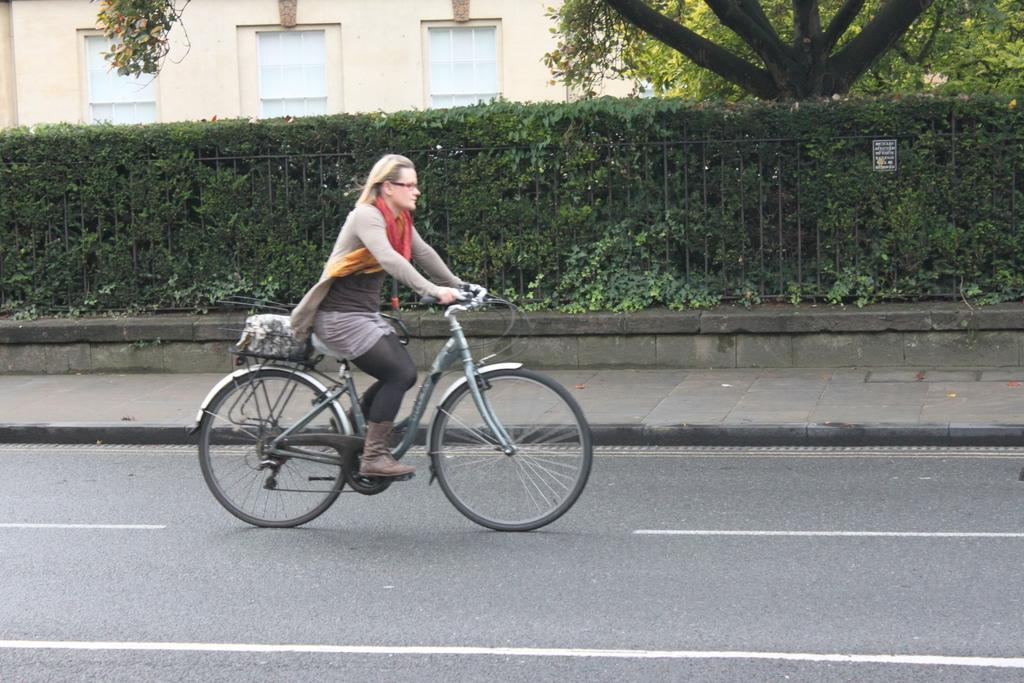What is the woman in the image doing? The woman is riding a bicycle in the image. What can be seen in the foreground of the image? There is a road and a footpath alongside the road in the image. What is present in the background of the image? There is a fence, a wall with windows, and a tree in the background. Can you describe the sticker on the fence in the background? There is a sticker on the fence in the background, but its design or content cannot be determined from the image. What type of silk fabric is draped over the tree in the image? There is no silk fabric present in the image; the tree is not draped with any fabric. 